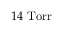Convert formula to latex. <formula><loc_0><loc_0><loc_500><loc_500>1 4 T o r r</formula> 